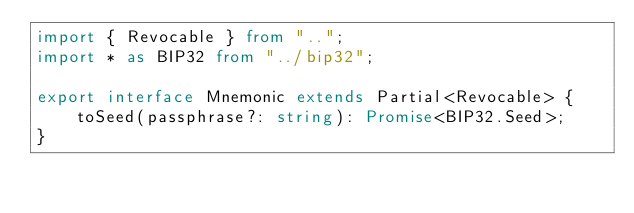Convert code to text. <code><loc_0><loc_0><loc_500><loc_500><_TypeScript_>import { Revocable } from "..";
import * as BIP32 from "../bip32";

export interface Mnemonic extends Partial<Revocable> {
    toSeed(passphrase?: string): Promise<BIP32.Seed>;
}
</code> 